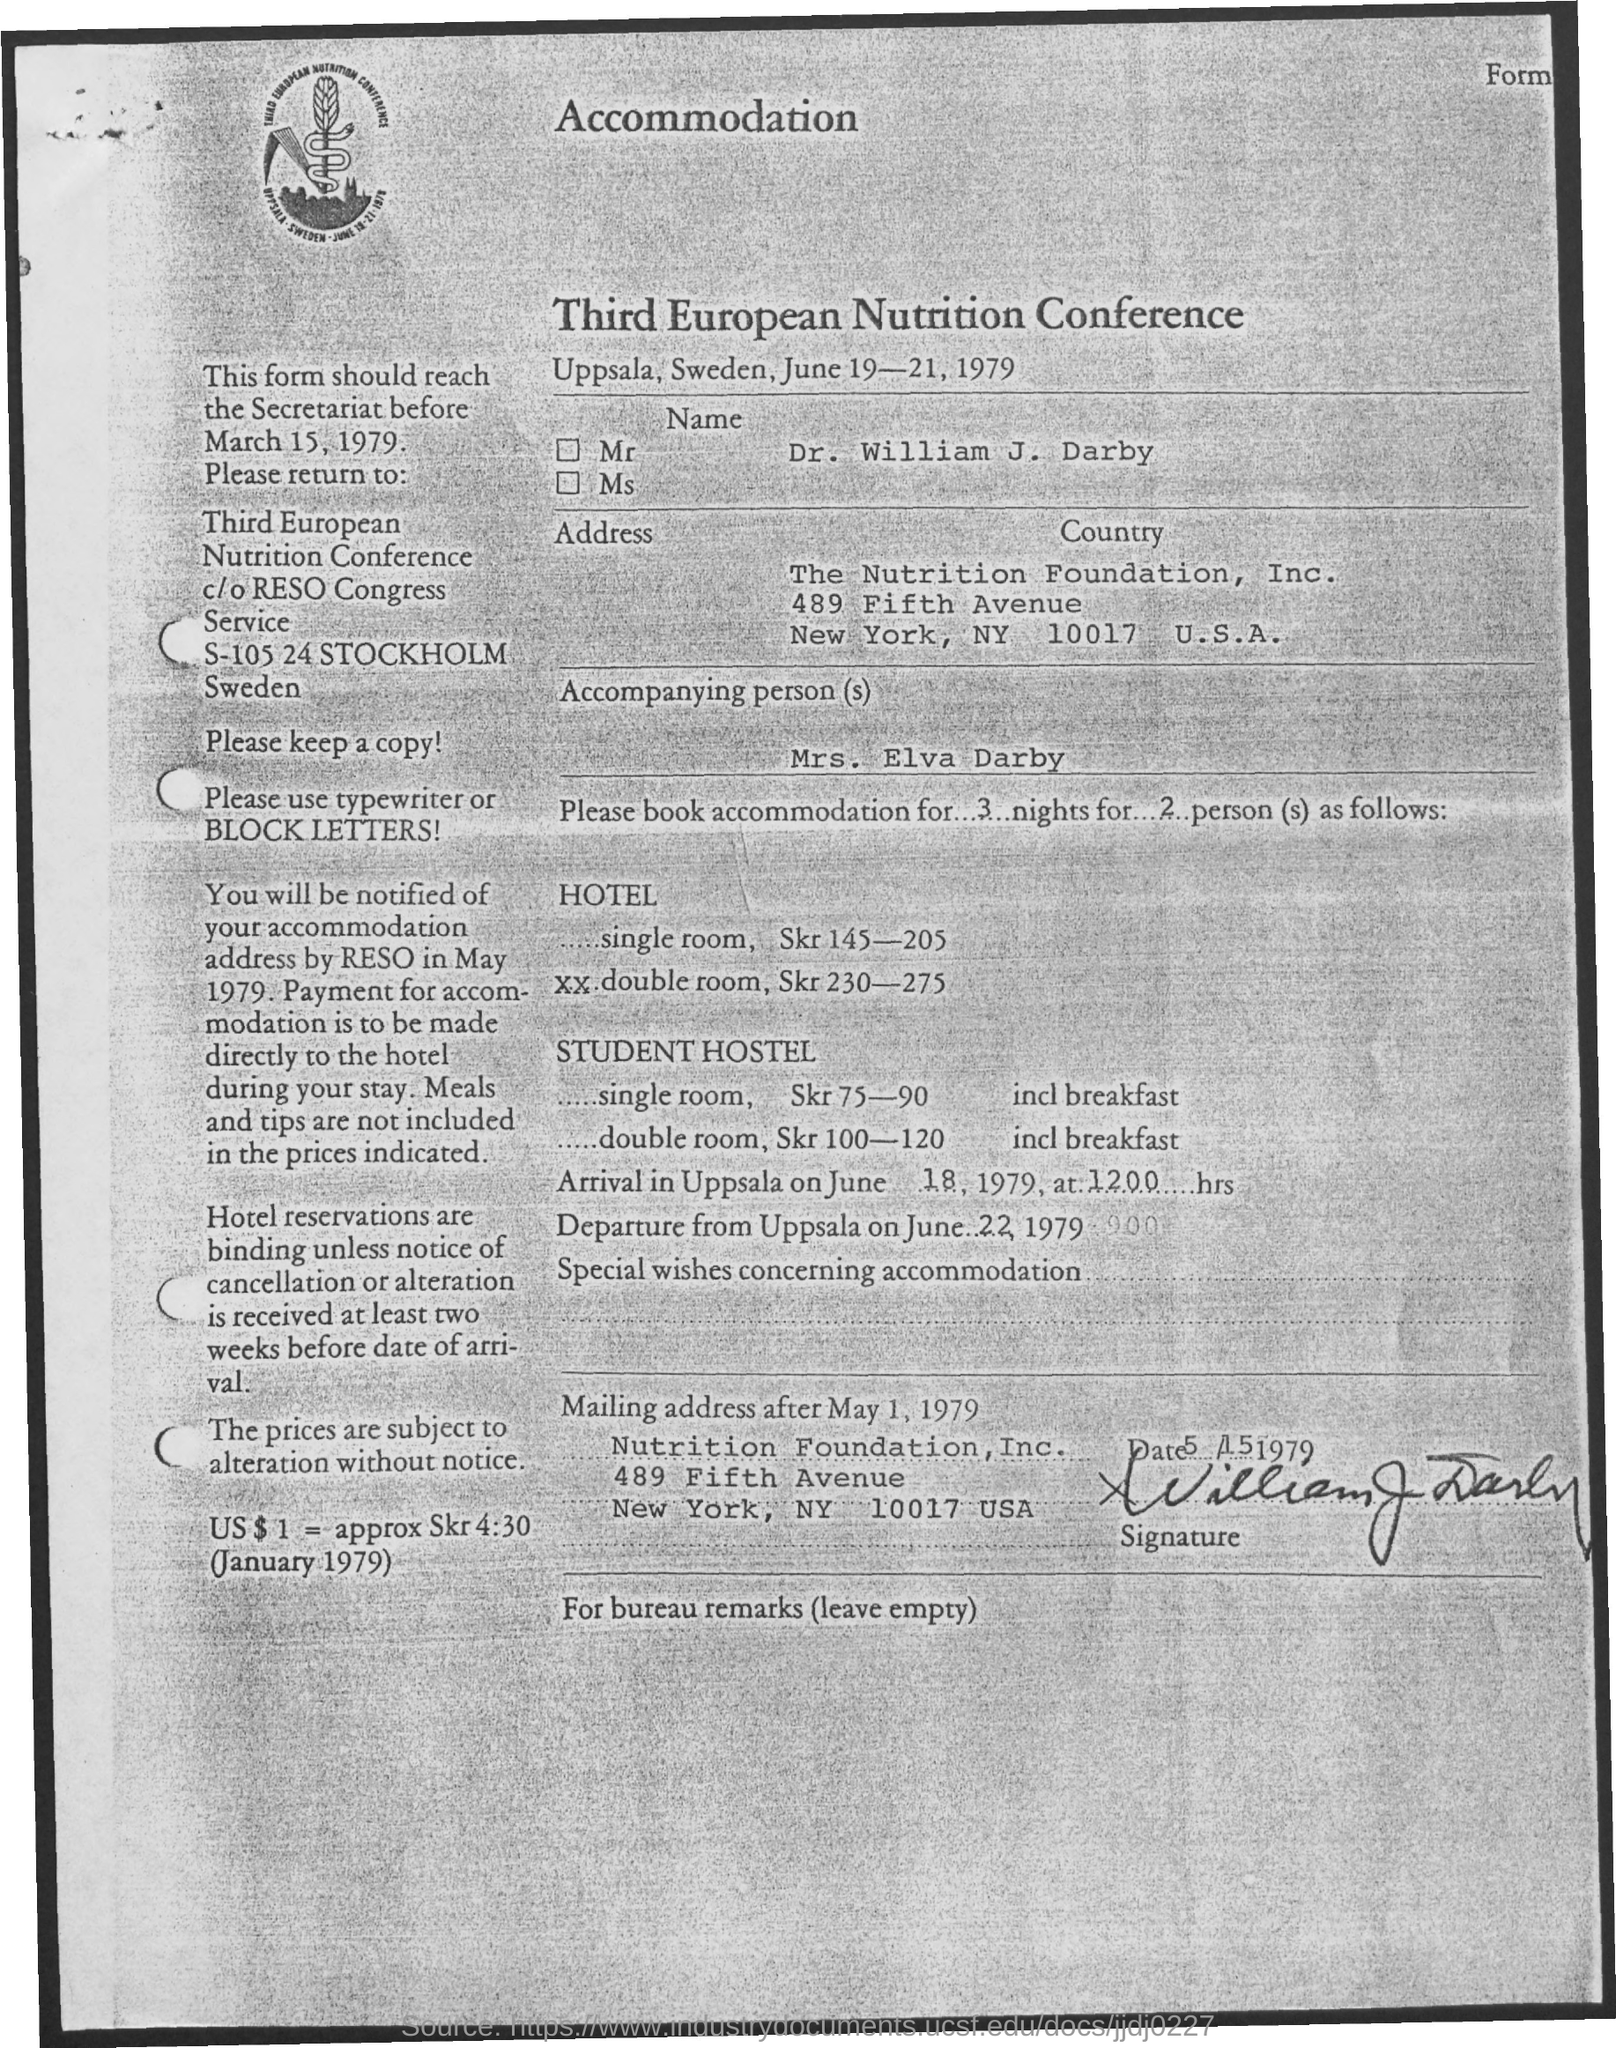Point out several critical features in this image. The city mentioned in the address is New York. Dr. William J. Darby is the name of the person. This form is to be received by the secretariat before March 15, 1979. The accompanying person is Mrs. Elva Darby. The Third European Nutrition Conference was held from June 19-21, 1979. 